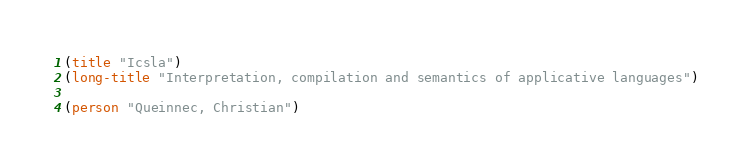<code> <loc_0><loc_0><loc_500><loc_500><_Scheme_>(title "Icsla")
(long-title "Interpretation, compilation and semantics of applicative languages")

(person "Queinnec, Christian")
</code> 